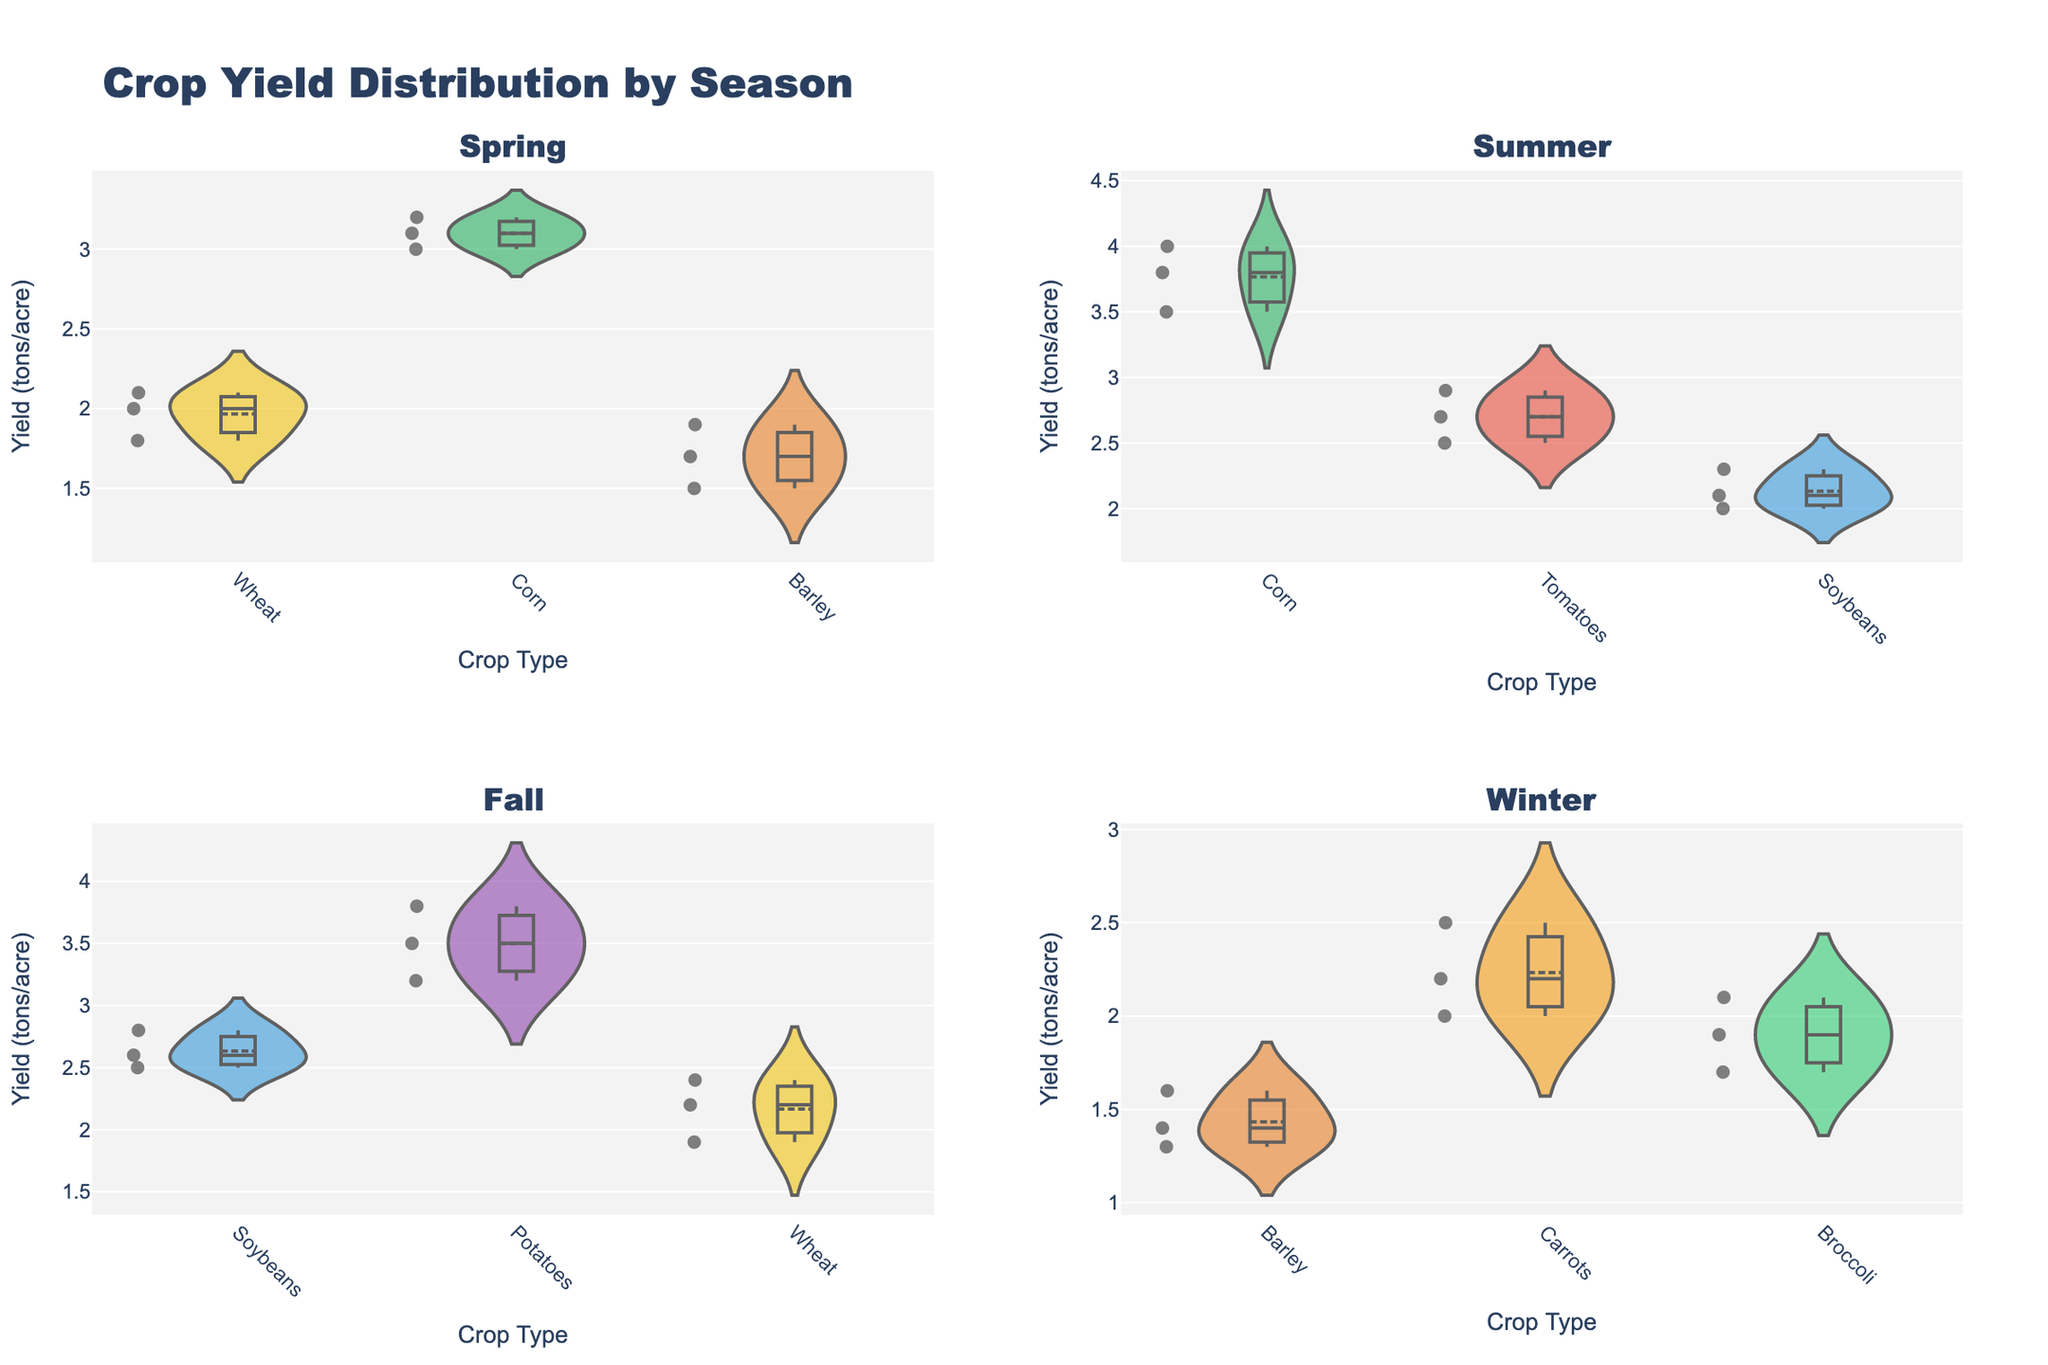What is the title of the figure? The title of the figure is displayed prominently at the top in a large, bold font, indicating the main focus of the visual.
Answer: Crop Yield Distribution by Season How many subplots are there in the figure? The figure is divided into four sections, each representing a subplot for the different seasons.
Answer: 4 What crop has the highest yield in the Spring season? By inspecting the Spring subplot, the crop with the highest yield can be identified by the peak of the violin plot. Corn has the highest peak in Spring.
Answer: Corn Which season shows the yield distribution for Broccoli? By examining each subplot's title, we can see that Broccoli is only represented in the Winter subplot.
Answer: Winter How does the variability of Corn yields compare between Spring and Summer? Comparing the width and spread of the violin plots for Corn in both Spring and Summer subplots shows that Corn yields in Summer have a wider spread, indicating more variability.
Answer: Greater in Summer Which crop has the lowest average yield in the Winter season? By looking at the mean lines within the Winter subplot, the crop with the lowest positioning is Barley.
Answer: Barley In which season is the median yield of Soybeans the highest? Reviewing the mean/median markers in the Soybeans plots across seasons, we see that the highest median yield is found in the Fall season.
Answer: Fall What is the range of yields for Potatoes in the Fall season? By examining the endpoints of the Potatoes violin plot in the Fall subplot, the range spans from approximately 3.2 to 3.8 tons per acre.
Answer: 3.2 to 3.8 tons/acre Which crop in the Summer season has the narrowest yield distribution? Observing the widths and narrowness of the violin plots in Summer, Tomatoes show the narrowest distribution of yields.
Answer: Tomatoes How does the yield distribution of Carrots in Winter compare to Tomatoes in Summer? Both distributions are displayed, and Carrots in Winter show a wider spread compared to Tomatoes in Summer, indicating that Carrots have more variability in yields.
Answer: Carrots have more variability 